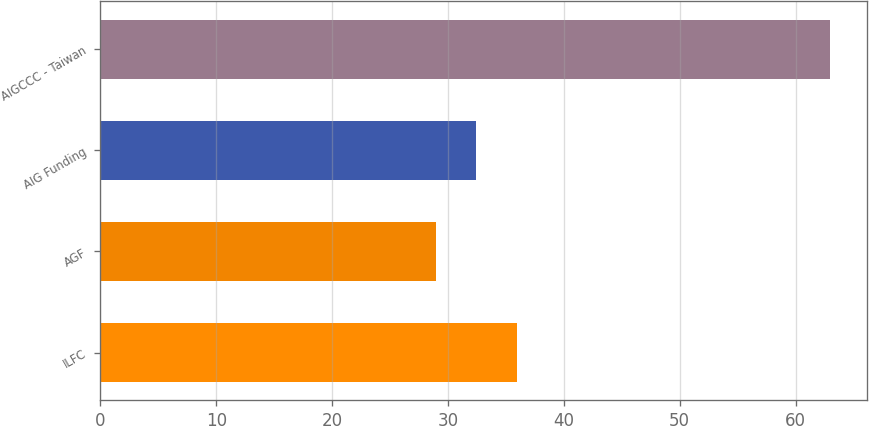<chart> <loc_0><loc_0><loc_500><loc_500><bar_chart><fcel>ILFC<fcel>AGF<fcel>AIG Funding<fcel>AIGCCC - Taiwan<nl><fcel>36<fcel>29<fcel>32.4<fcel>63<nl></chart> 